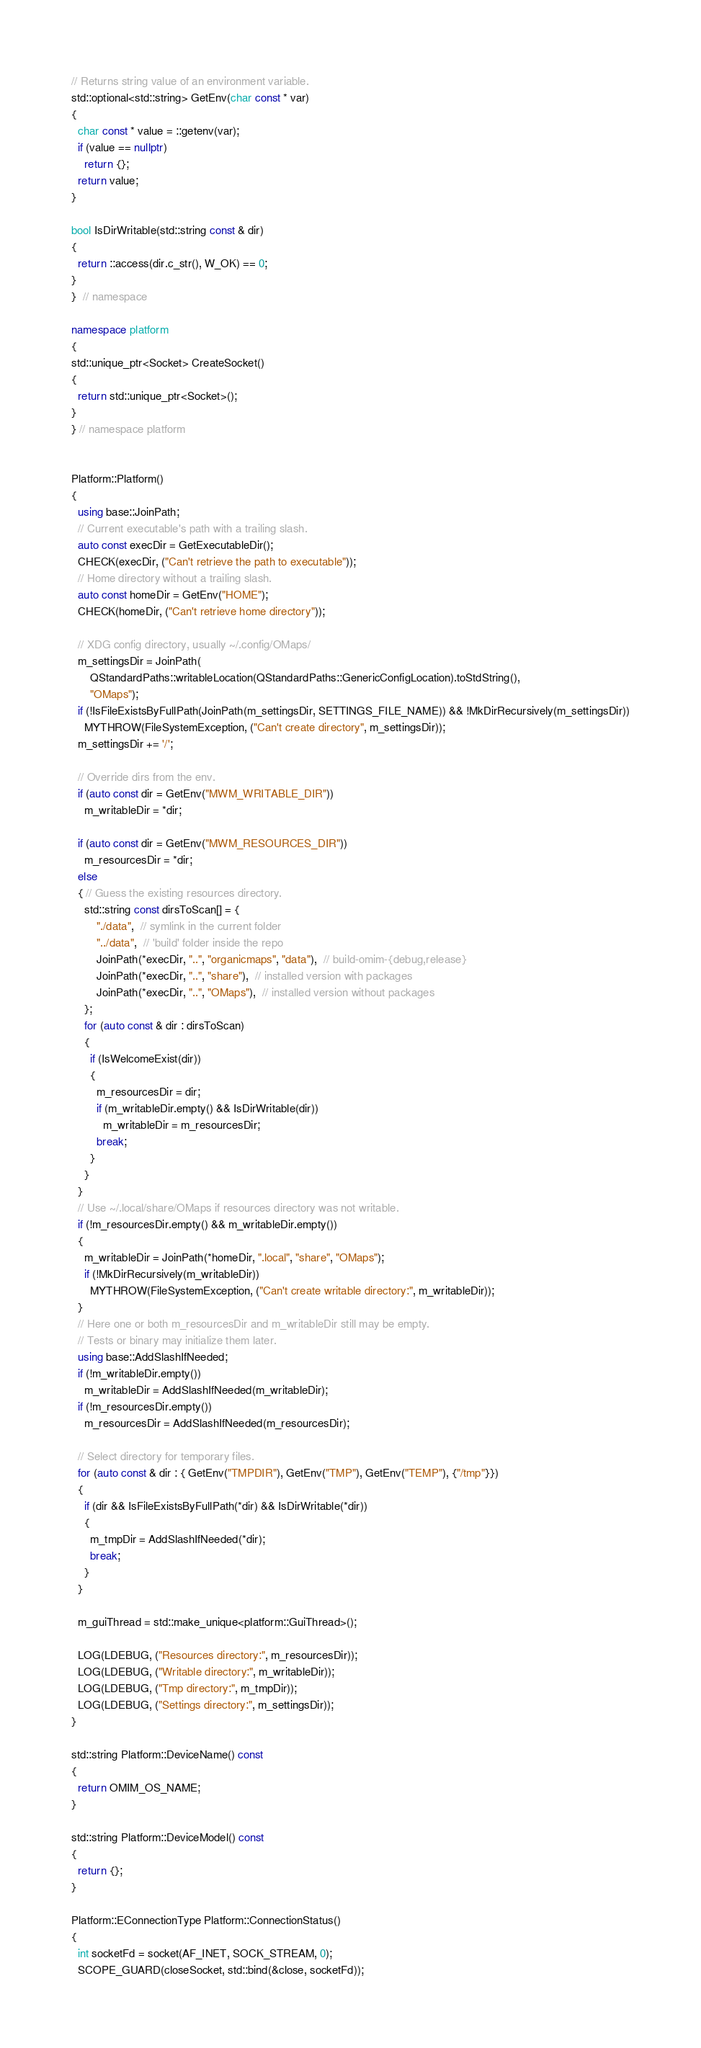Convert code to text. <code><loc_0><loc_0><loc_500><loc_500><_C++_>// Returns string value of an environment variable.
std::optional<std::string> GetEnv(char const * var)
{
  char const * value = ::getenv(var);
  if (value == nullptr)
    return {};
  return value;
}

bool IsDirWritable(std::string const & dir)
{
  return ::access(dir.c_str(), W_OK) == 0;
}
}  // namespace

namespace platform
{
std::unique_ptr<Socket> CreateSocket()
{
  return std::unique_ptr<Socket>();
}
} // namespace platform


Platform::Platform()
{
  using base::JoinPath;
  // Current executable's path with a trailing slash.
  auto const execDir = GetExecutableDir();
  CHECK(execDir, ("Can't retrieve the path to executable"));
  // Home directory without a trailing slash.
  auto const homeDir = GetEnv("HOME");
  CHECK(homeDir, ("Can't retrieve home directory"));

  // XDG config directory, usually ~/.config/OMaps/
  m_settingsDir = JoinPath(
      QStandardPaths::writableLocation(QStandardPaths::GenericConfigLocation).toStdString(),
      "OMaps");
  if (!IsFileExistsByFullPath(JoinPath(m_settingsDir, SETTINGS_FILE_NAME)) && !MkDirRecursively(m_settingsDir))
    MYTHROW(FileSystemException, ("Can't create directory", m_settingsDir));
  m_settingsDir += '/';

  // Override dirs from the env.
  if (auto const dir = GetEnv("MWM_WRITABLE_DIR"))
    m_writableDir = *dir;

  if (auto const dir = GetEnv("MWM_RESOURCES_DIR"))
    m_resourcesDir = *dir;
  else
  { // Guess the existing resources directory.
    std::string const dirsToScan[] = {
        "./data",  // symlink in the current folder
        "../data",  // 'build' folder inside the repo
        JoinPath(*execDir, "..", "organicmaps", "data"),  // build-omim-{debug,release}
        JoinPath(*execDir, "..", "share"),  // installed version with packages
        JoinPath(*execDir, "..", "OMaps"),  // installed version without packages
    };
    for (auto const & dir : dirsToScan)
    {
      if (IsWelcomeExist(dir))
      {
        m_resourcesDir = dir;
        if (m_writableDir.empty() && IsDirWritable(dir))
          m_writableDir = m_resourcesDir;
        break;
      }
    }
  }
  // Use ~/.local/share/OMaps if resources directory was not writable.
  if (!m_resourcesDir.empty() && m_writableDir.empty())
  {
    m_writableDir = JoinPath(*homeDir, ".local", "share", "OMaps");
    if (!MkDirRecursively(m_writableDir))
      MYTHROW(FileSystemException, ("Can't create writable directory:", m_writableDir));
  }
  // Here one or both m_resourcesDir and m_writableDir still may be empty.
  // Tests or binary may initialize them later.
  using base::AddSlashIfNeeded;
  if (!m_writableDir.empty())
    m_writableDir = AddSlashIfNeeded(m_writableDir);
  if (!m_resourcesDir.empty())
    m_resourcesDir = AddSlashIfNeeded(m_resourcesDir);

  // Select directory for temporary files.
  for (auto const & dir : { GetEnv("TMPDIR"), GetEnv("TMP"), GetEnv("TEMP"), {"/tmp"}})
  {
    if (dir && IsFileExistsByFullPath(*dir) && IsDirWritable(*dir))
    {
      m_tmpDir = AddSlashIfNeeded(*dir);
      break;
    }
  }

  m_guiThread = std::make_unique<platform::GuiThread>();

  LOG(LDEBUG, ("Resources directory:", m_resourcesDir));
  LOG(LDEBUG, ("Writable directory:", m_writableDir));
  LOG(LDEBUG, ("Tmp directory:", m_tmpDir));
  LOG(LDEBUG, ("Settings directory:", m_settingsDir));
}

std::string Platform::DeviceName() const
{
  return OMIM_OS_NAME;
}

std::string Platform::DeviceModel() const
{
  return {};
}

Platform::EConnectionType Platform::ConnectionStatus()
{
  int socketFd = socket(AF_INET, SOCK_STREAM, 0);
  SCOPE_GUARD(closeSocket, std::bind(&close, socketFd));</code> 